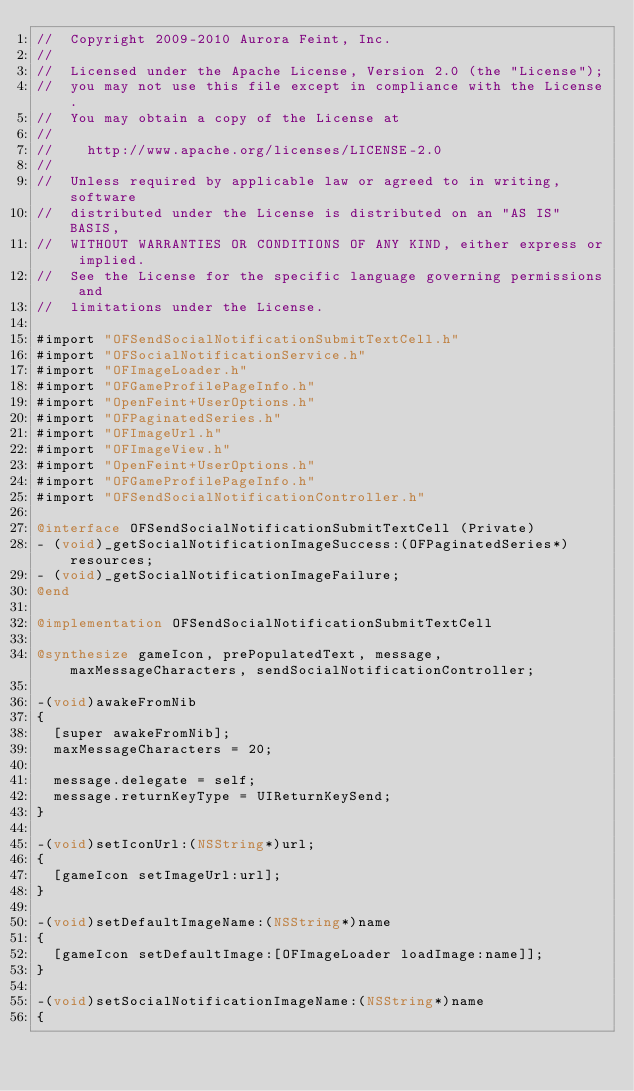Convert code to text. <code><loc_0><loc_0><loc_500><loc_500><_ObjectiveC_>//  Copyright 2009-2010 Aurora Feint, Inc.
// 
//  Licensed under the Apache License, Version 2.0 (the "License");
//  you may not use this file except in compliance with the License.
//  You may obtain a copy of the License at
//  
//  	http://www.apache.org/licenses/LICENSE-2.0
//  	
//  Unless required by applicable law or agreed to in writing, software
//  distributed under the License is distributed on an "AS IS" BASIS,
//  WITHOUT WARRANTIES OR CONDITIONS OF ANY KIND, either express or implied.
//  See the License for the specific language governing permissions and
//  limitations under the License.

#import "OFSendSocialNotificationSubmitTextCell.h"
#import "OFSocialNotificationService.h"
#import "OFImageLoader.h"
#import "OFGameProfilePageInfo.h"
#import "OpenFeint+UserOptions.h"
#import "OFPaginatedSeries.h"
#import "OFImageUrl.h"
#import "OFImageView.h"
#import "OpenFeint+UserOptions.h"
#import "OFGameProfilePageInfo.h"
#import "OFSendSocialNotificationController.h"

@interface OFSendSocialNotificationSubmitTextCell (Private)
- (void)_getSocialNotificationImageSuccess:(OFPaginatedSeries*)resources;
- (void)_getSocialNotificationImageFailure;
@end

@implementation OFSendSocialNotificationSubmitTextCell

@synthesize gameIcon, prePopulatedText, message, maxMessageCharacters, sendSocialNotificationController;

-(void)awakeFromNib
{
	[super awakeFromNib];
	maxMessageCharacters = 20;
	
	message.delegate = self;
	message.returnKeyType = UIReturnKeySend;
}

-(void)setIconUrl:(NSString*)url;
{
	[gameIcon setImageUrl:url];
}

-(void)setDefaultImageName:(NSString*)name
{
	[gameIcon setDefaultImage:[OFImageLoader loadImage:name]];
}

-(void)setSocialNotificationImageName:(NSString*)name
{</code> 